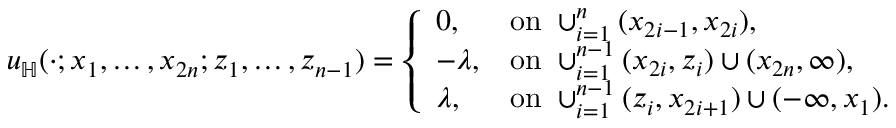Convert formula to latex. <formula><loc_0><loc_0><loc_500><loc_500>\begin{array} { r } { u _ { \mathbb { H } } ( \cdot ; x _ { 1 } , \dots , x _ { 2 n } ; z _ { 1 } , \dots , z _ { n - 1 } ) = \left \{ \begin{array} { l l } { 0 , } & { o n \cup _ { i = 1 } ^ { n } ( x _ { 2 i - 1 } , x _ { 2 i } ) , } \\ { - \lambda , } & { o n \cup _ { i = 1 } ^ { n - 1 } ( x _ { 2 i } , z _ { i } ) \cup ( x _ { 2 n } , \infty ) , } \\ { \lambda , } & { o n \cup _ { i = 1 } ^ { n - 1 } ( z _ { i } , x _ { 2 i + 1 } ) \cup ( - \infty , x _ { 1 } ) . } \end{array} } \end{array}</formula> 